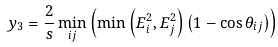<formula> <loc_0><loc_0><loc_500><loc_500>y _ { 3 } = \frac { 2 } { s } \min _ { i j } \left ( \min \left ( E _ { i } ^ { 2 } , E _ { j } ^ { 2 } \right ) \left ( 1 - \cos \theta _ { i j } \right ) \right )</formula> 